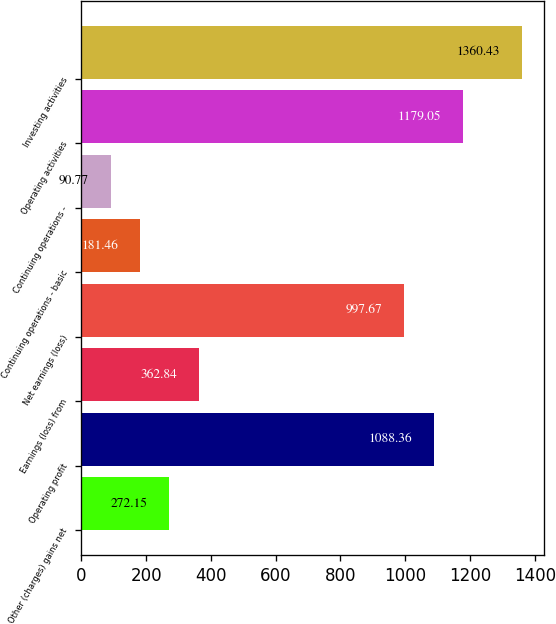<chart> <loc_0><loc_0><loc_500><loc_500><bar_chart><fcel>Other (charges) gains net<fcel>Operating profit<fcel>Earnings (loss) from<fcel>Net earnings (loss)<fcel>Continuing operations - basic<fcel>Continuing operations -<fcel>Operating activities<fcel>Investing activities<nl><fcel>272.15<fcel>1088.36<fcel>362.84<fcel>997.67<fcel>181.46<fcel>90.77<fcel>1179.05<fcel>1360.43<nl></chart> 